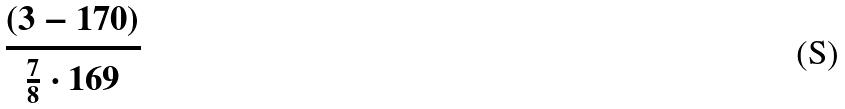Convert formula to latex. <formula><loc_0><loc_0><loc_500><loc_500>\frac { ( 3 - 1 7 0 ) } { \frac { 7 } { 8 } \cdot 1 6 9 }</formula> 